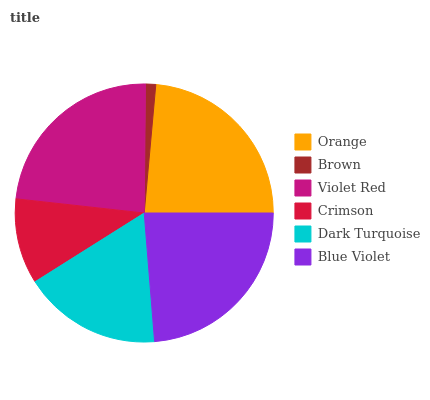Is Brown the minimum?
Answer yes or no. Yes. Is Blue Violet the maximum?
Answer yes or no. Yes. Is Violet Red the minimum?
Answer yes or no. No. Is Violet Red the maximum?
Answer yes or no. No. Is Violet Red greater than Brown?
Answer yes or no. Yes. Is Brown less than Violet Red?
Answer yes or no. Yes. Is Brown greater than Violet Red?
Answer yes or no. No. Is Violet Red less than Brown?
Answer yes or no. No. Is Violet Red the high median?
Answer yes or no. Yes. Is Dark Turquoise the low median?
Answer yes or no. Yes. Is Brown the high median?
Answer yes or no. No. Is Blue Violet the low median?
Answer yes or no. No. 